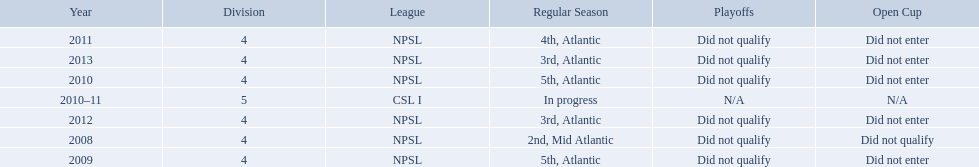What are the leagues? NPSL, NPSL, NPSL, CSL I, NPSL, NPSL, NPSL. Of these, what league is not npsl? CSL I. 